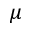Convert formula to latex. <formula><loc_0><loc_0><loc_500><loc_500>\mu</formula> 